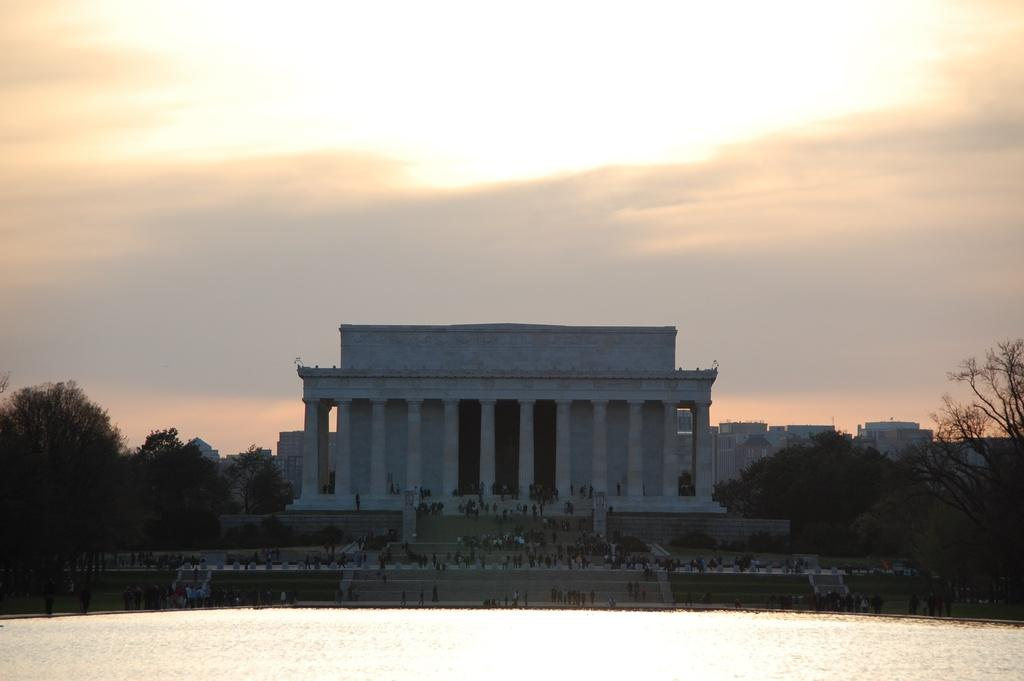What is visible in the foreground of the image? There is water in the foreground of the image. What can be seen in the center of the image? There are trees and buildings in the center of the image. Where are the people located in the image? The people are on a staircase in the image. What is the condition of the sky in the image? The sky is cloudy in the image. Is there a stove visible in the image? No, there is no stove present in the image. Does the existence of the people on the staircase prove the existence of a higher power? The presence of people on a staircase in the image does not prove the existence of a higher power; it is simply a detail about the image. 